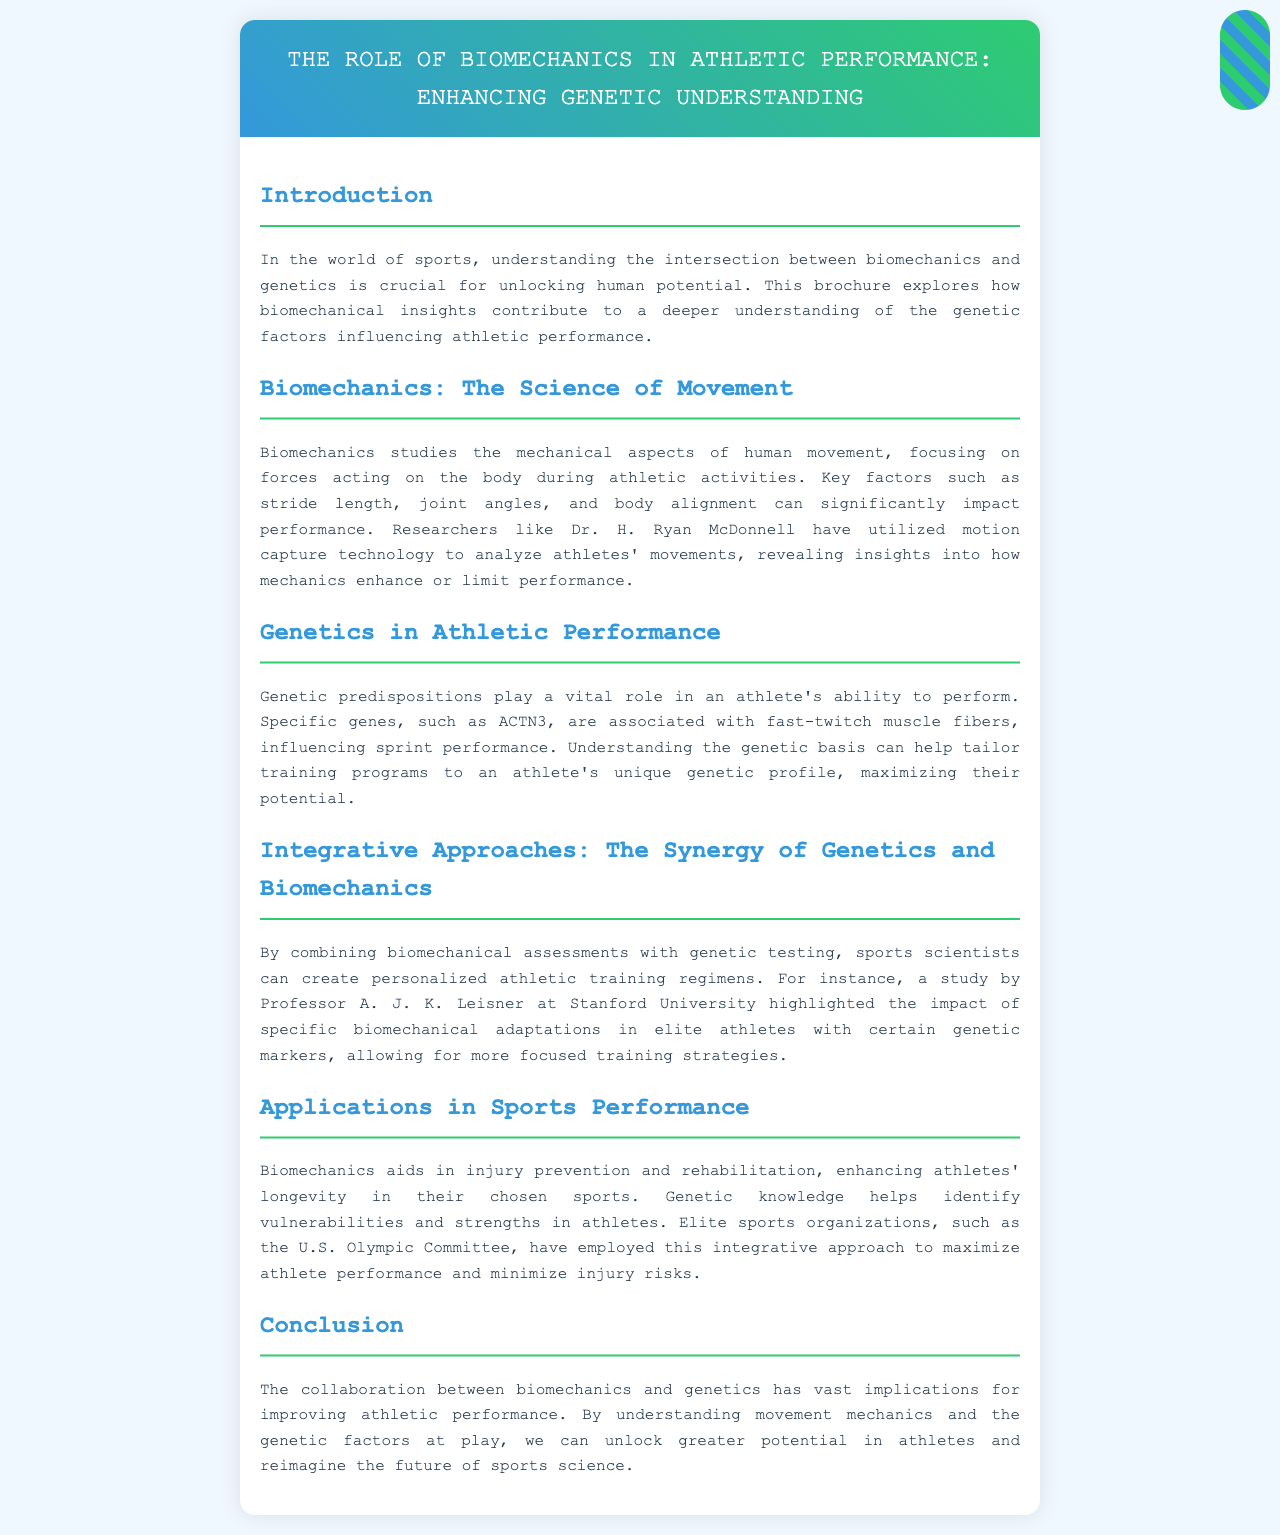What is the focus of biomechanics? Biomechanics focuses on the mechanical aspects of human movement, specifically the forces acting on the body during athletic activities.
Answer: mechanical aspects of human movement Who utilized motion capture technology for analysis? Dr. H. Ryan McDonnell is mentioned as a researcher who has utilized motion capture technology to analyze athletes' movements.
Answer: Dr. H. Ryan McDonnell Which gene is associated with fast-twitch muscle fibers? The ACTN3 gene is associated with fast-twitch muscle fibers, influencing sprint performance.
Answer: ACTN3 What does the integration of biomechanics and genetics help create? The integration of biomechanics and genetics helps create personalized athletic training regimens.
Answer: personalized athletic training regimens Which organization has employed an integrative approach in athlete performance? The U.S. Olympic Committee is the organization mentioned that has employed this integrative approach.
Answer: U.S. Olympic Committee What aspect does biomechanics aid in regarding athletes? Biomechanics aids in injury prevention and rehabilitation, enhancing athlete longevity.
Answer: injury prevention and rehabilitation Who conducted a study on biomechanical adaptations in elite athletes? Professor A. J. K. Leisner conducted a study highlighted in the brochure.
Answer: Professor A. J. K. Leisner What is the broader implication of collaboration between biomechanics and genetics? The broader implication is improving athletic performance and unlocking greater potential in athletes.
Answer: improving athletic performance 